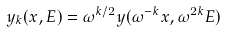Convert formula to latex. <formula><loc_0><loc_0><loc_500><loc_500>y _ { k } ( x , E ) = \omega ^ { k / 2 } y ( \omega ^ { - k } x , \omega ^ { 2 k } E )</formula> 